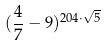Convert formula to latex. <formula><loc_0><loc_0><loc_500><loc_500>( \frac { 4 } { 7 } - 9 ) ^ { 2 0 4 \cdot \sqrt { 5 } }</formula> 